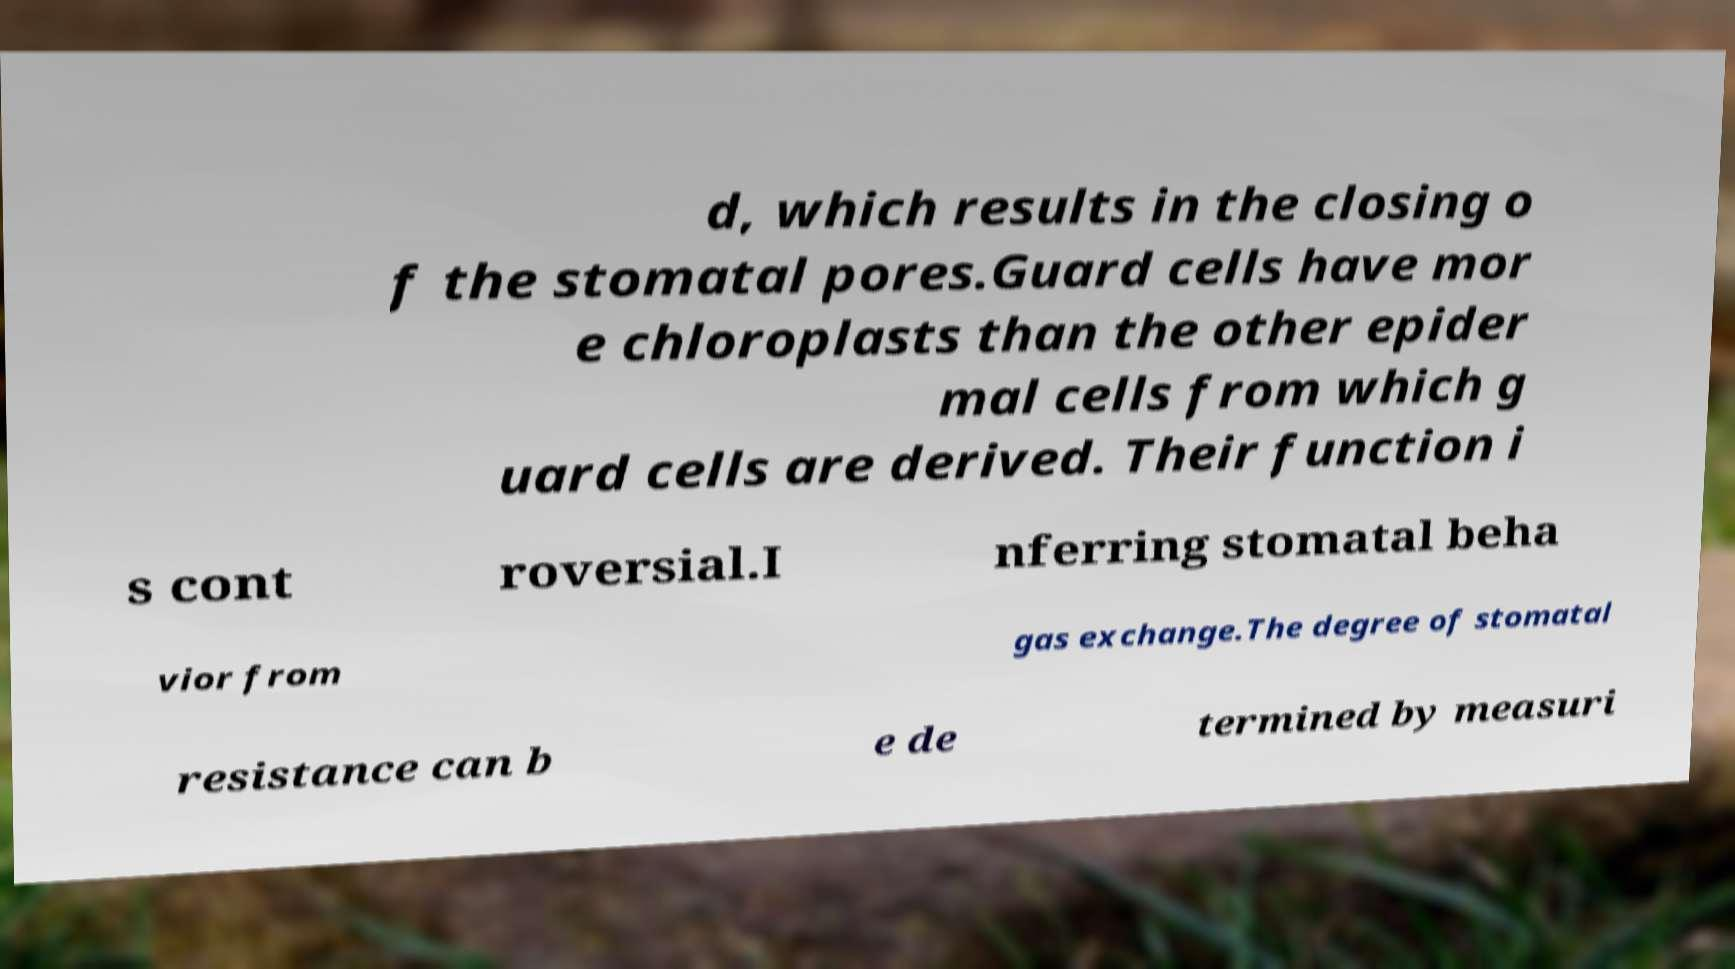Could you extract and type out the text from this image? d, which results in the closing o f the stomatal pores.Guard cells have mor e chloroplasts than the other epider mal cells from which g uard cells are derived. Their function i s cont roversial.I nferring stomatal beha vior from gas exchange.The degree of stomatal resistance can b e de termined by measuri 